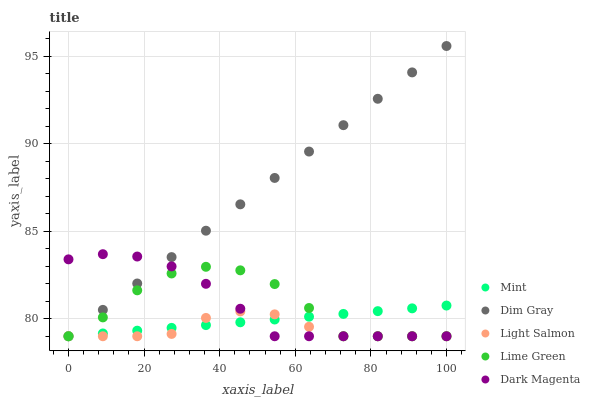Does Light Salmon have the minimum area under the curve?
Answer yes or no. Yes. Does Dim Gray have the maximum area under the curve?
Answer yes or no. Yes. Does Dim Gray have the minimum area under the curve?
Answer yes or no. No. Does Light Salmon have the maximum area under the curve?
Answer yes or no. No. Is Mint the smoothest?
Answer yes or no. Yes. Is Lime Green the roughest?
Answer yes or no. Yes. Is Light Salmon the smoothest?
Answer yes or no. No. Is Light Salmon the roughest?
Answer yes or no. No. Does Lime Green have the lowest value?
Answer yes or no. Yes. Does Dim Gray have the highest value?
Answer yes or no. Yes. Does Light Salmon have the highest value?
Answer yes or no. No. Does Light Salmon intersect Lime Green?
Answer yes or no. Yes. Is Light Salmon less than Lime Green?
Answer yes or no. No. Is Light Salmon greater than Lime Green?
Answer yes or no. No. 